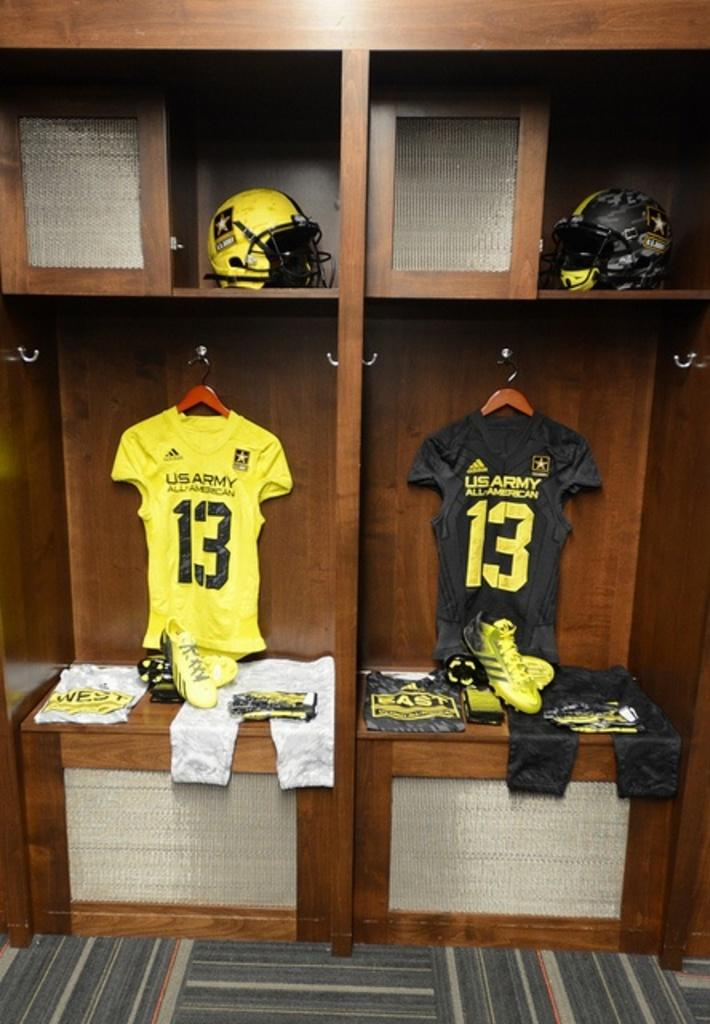Provide a one-sentence caption for the provided image. Two Jerseys with the number 13 and US Army on the back sit in two lockers side by side. 